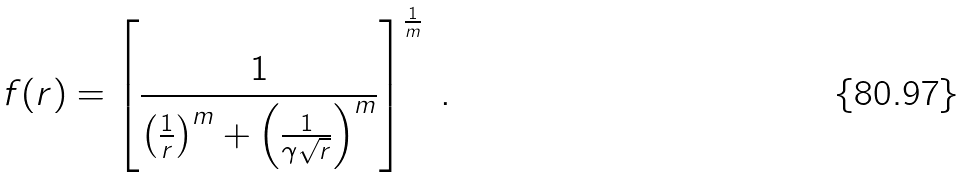<formula> <loc_0><loc_0><loc_500><loc_500>f ( r ) = \left [ \frac { 1 } { \left ( \frac { 1 } { r } \right ) ^ { m } + \left ( \frac { 1 } { \gamma \sqrt { r } } \right ) ^ { m } } \right ] ^ { \frac { 1 } { m } } \ .</formula> 